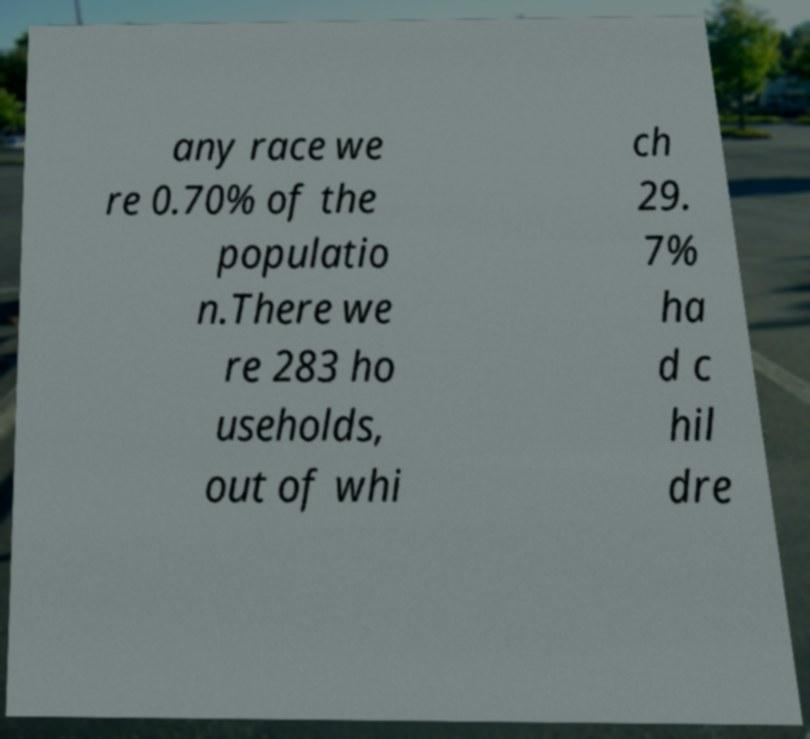Could you assist in decoding the text presented in this image and type it out clearly? any race we re 0.70% of the populatio n.There we re 283 ho useholds, out of whi ch 29. 7% ha d c hil dre 